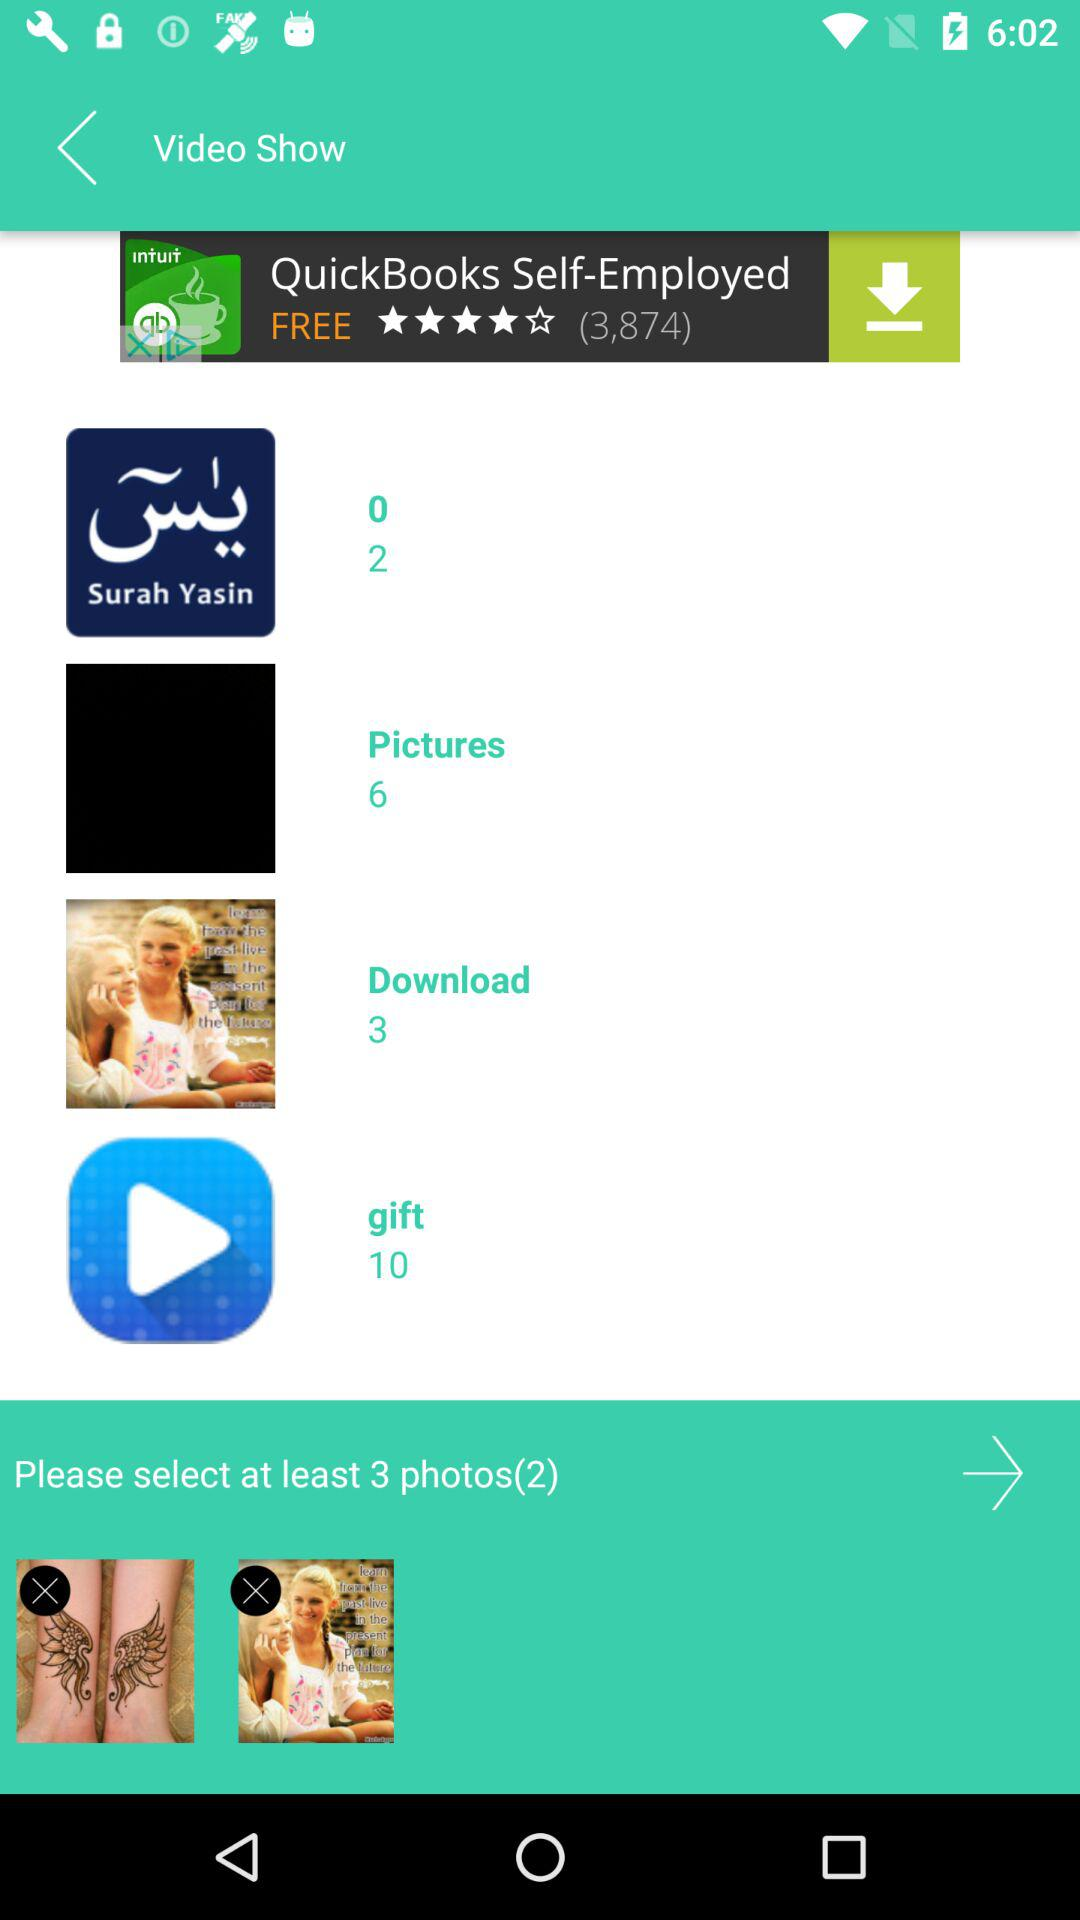What is the number of images in the "Pictures" album? The number of images in the "Pictures" album is 6. 